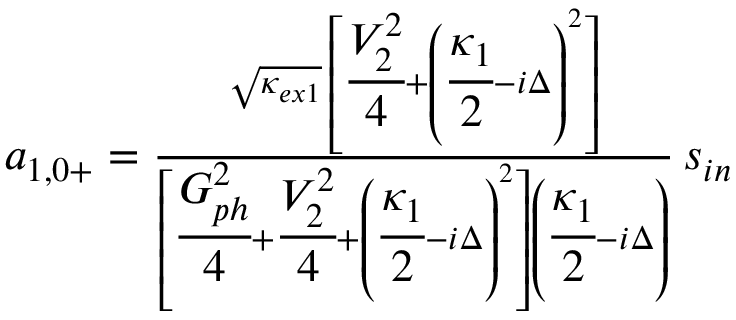Convert formula to latex. <formula><loc_0><loc_0><loc_500><loc_500>\begin{array} { r } { a _ { 1 , 0 + } = \frac { \sqrt { \kappa _ { e x 1 } } \, \left [ \cfrac { V _ { 2 } ^ { 2 } } { 4 } + \left ( \cfrac { \kappa _ { 1 } } { 2 } - i \Delta \right ) ^ { 2 } \right ] } { \left [ \cfrac { G _ { p h } ^ { 2 } } { 4 } + \cfrac { V _ { 2 } ^ { 2 } } { 4 } + \left ( \cfrac { \kappa _ { 1 } } { 2 } - i \Delta \right ) ^ { 2 } \right ] \left ( \cfrac { \kappa _ { 1 } } { 2 } - i \Delta \right ) } \, s _ { i n } } \end{array}</formula> 